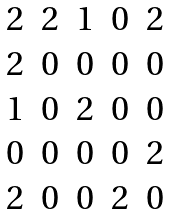<formula> <loc_0><loc_0><loc_500><loc_500>\begin{matrix} 2 & 2 & 1 & 0 & 2 \\ 2 & 0 & 0 & 0 & 0 \\ 1 & 0 & 2 & 0 & 0 \\ 0 & 0 & 0 & 0 & 2 \\ 2 & 0 & 0 & 2 & 0 \end{matrix}</formula> 